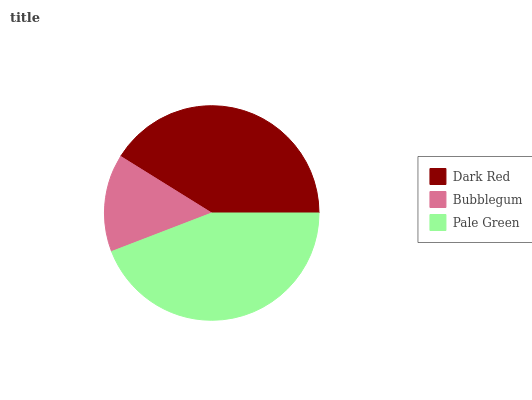Is Bubblegum the minimum?
Answer yes or no. Yes. Is Pale Green the maximum?
Answer yes or no. Yes. Is Pale Green the minimum?
Answer yes or no. No. Is Bubblegum the maximum?
Answer yes or no. No. Is Pale Green greater than Bubblegum?
Answer yes or no. Yes. Is Bubblegum less than Pale Green?
Answer yes or no. Yes. Is Bubblegum greater than Pale Green?
Answer yes or no. No. Is Pale Green less than Bubblegum?
Answer yes or no. No. Is Dark Red the high median?
Answer yes or no. Yes. Is Dark Red the low median?
Answer yes or no. Yes. Is Pale Green the high median?
Answer yes or no. No. Is Pale Green the low median?
Answer yes or no. No. 